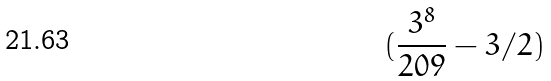<formula> <loc_0><loc_0><loc_500><loc_500>( \frac { 3 ^ { 8 } } { 2 0 9 } - 3 / 2 )</formula> 